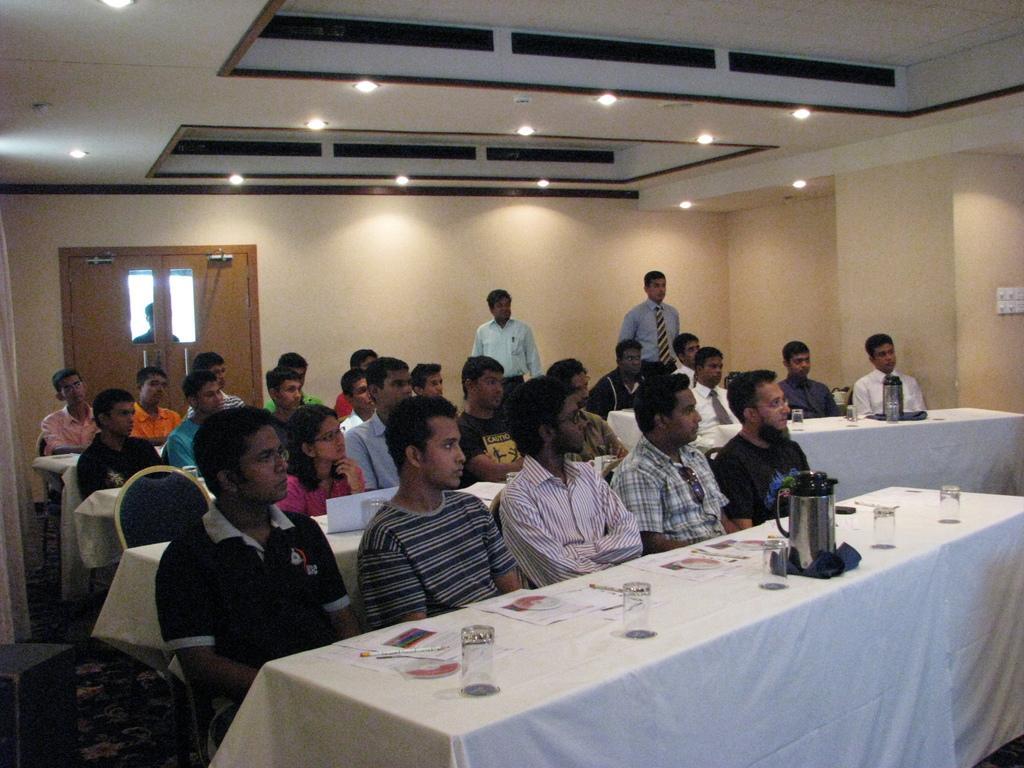In one or two sentences, can you explain what this image depicts? This picture shows a group of people seated on the chairs and we see few glasses and papers on the table and we see two men standing on the back. 